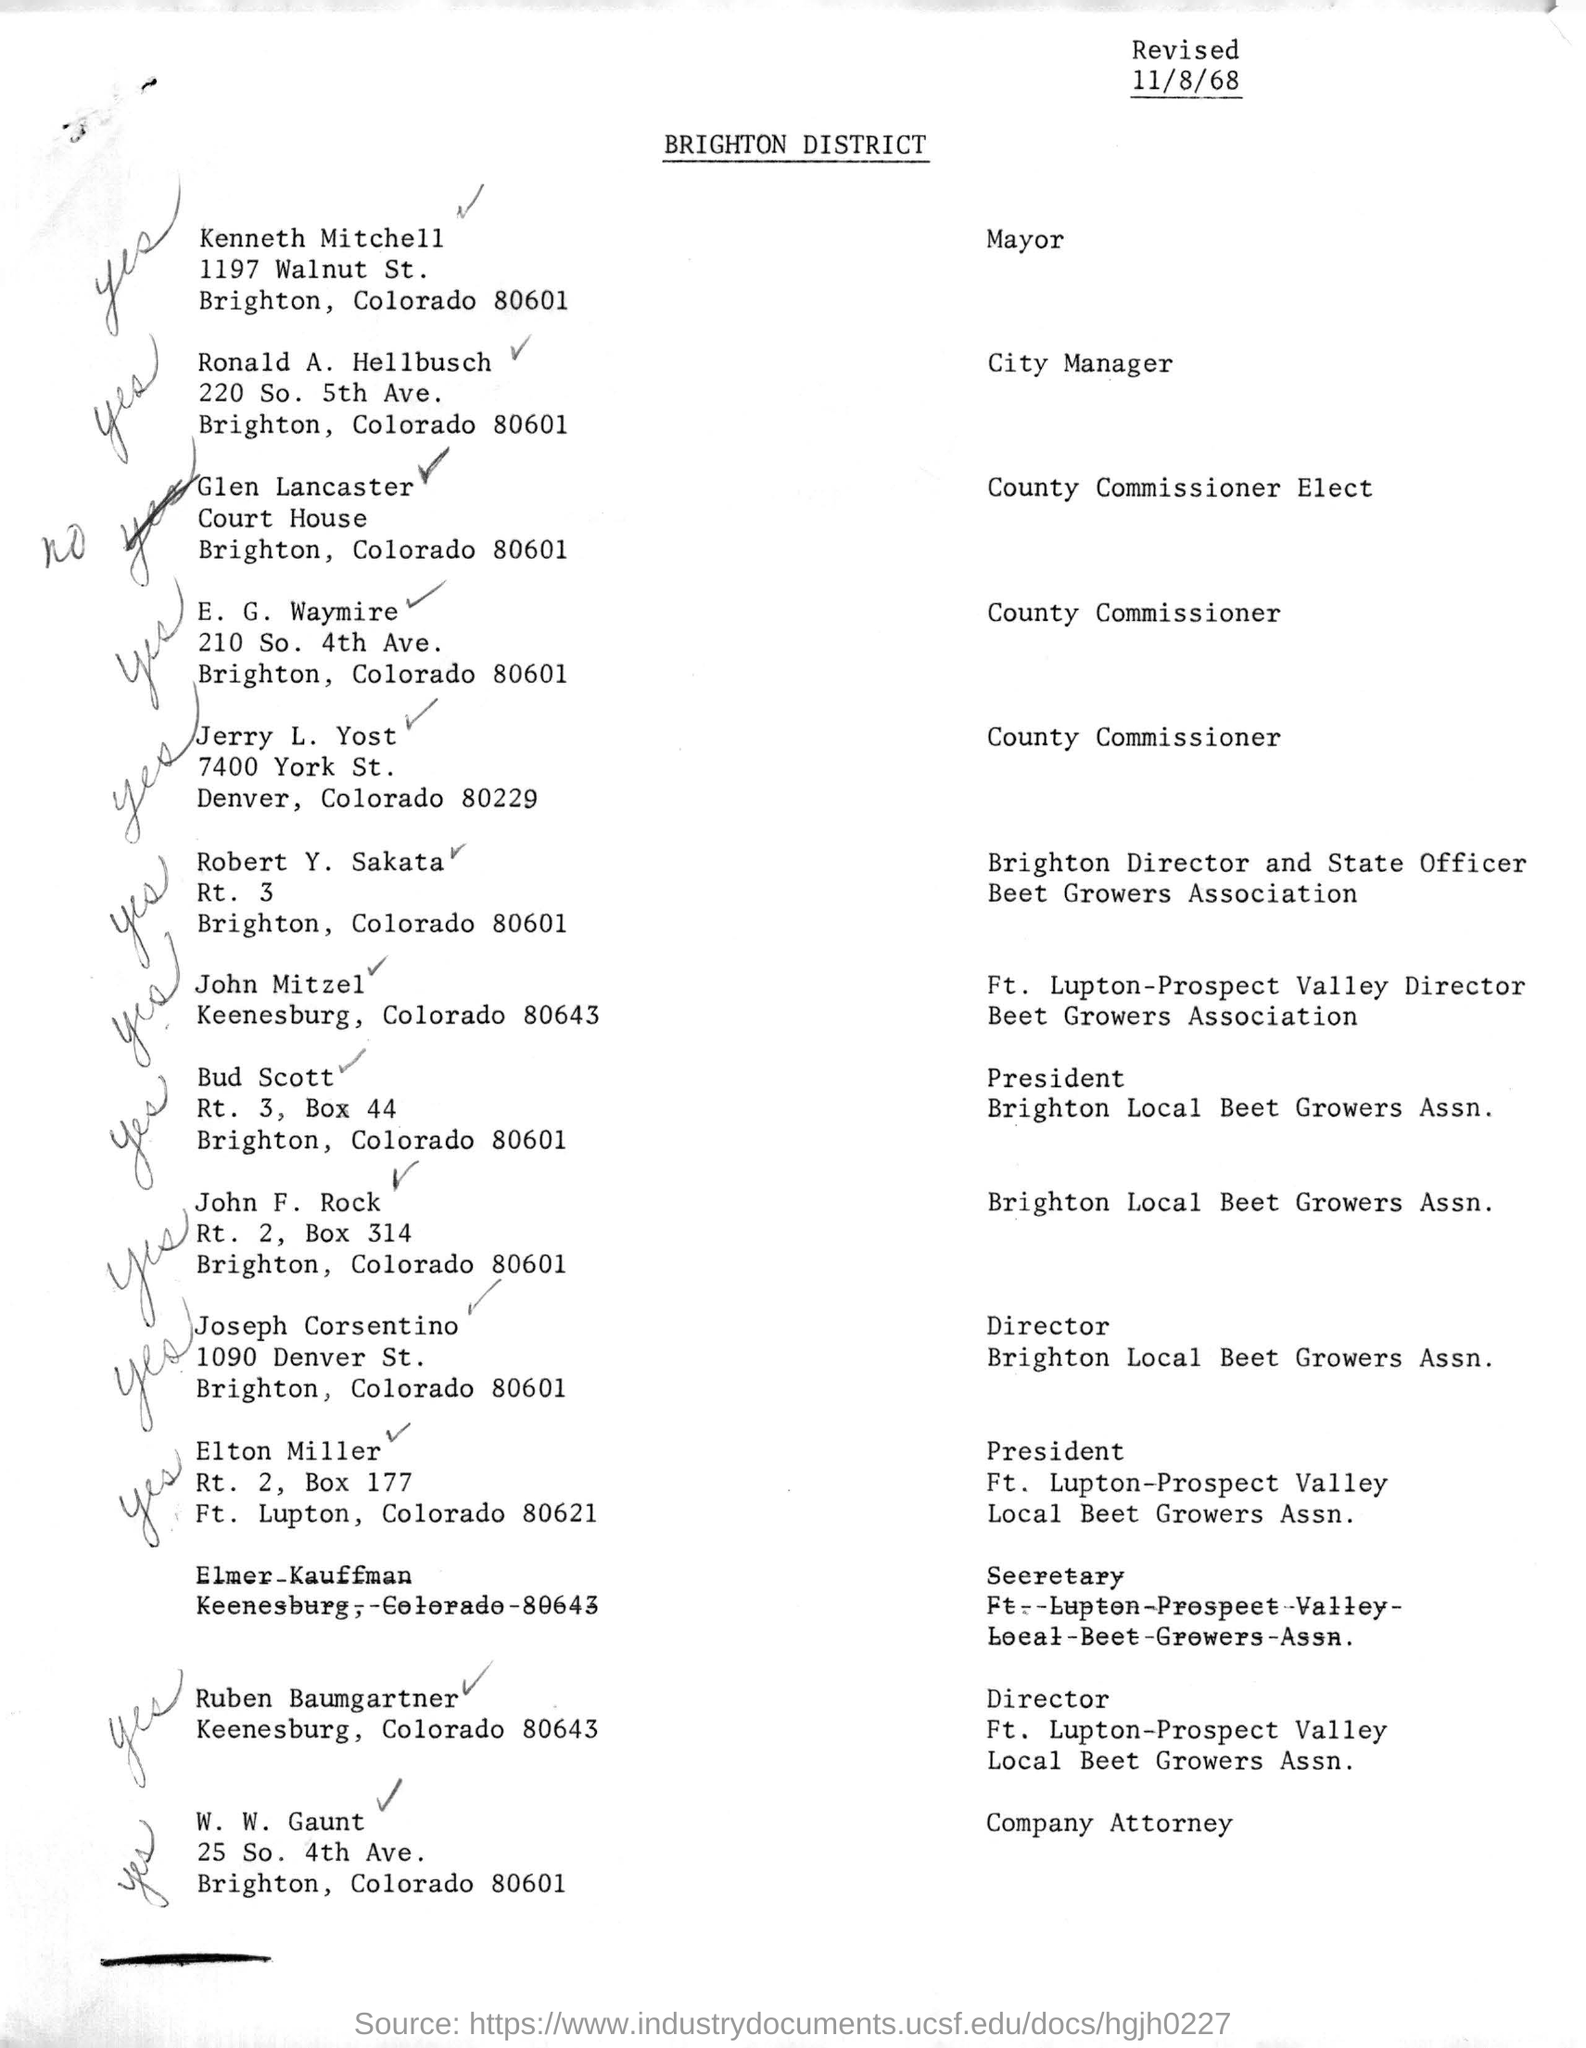Which is the date mentioned in the header?
Offer a very short reply. 11/8/68. What is the designation of Kenneth Mitchell?
Make the answer very short. Mayor. Which is the street address of Joseph Corsentino?
Keep it short and to the point. 1090 Denver St. 